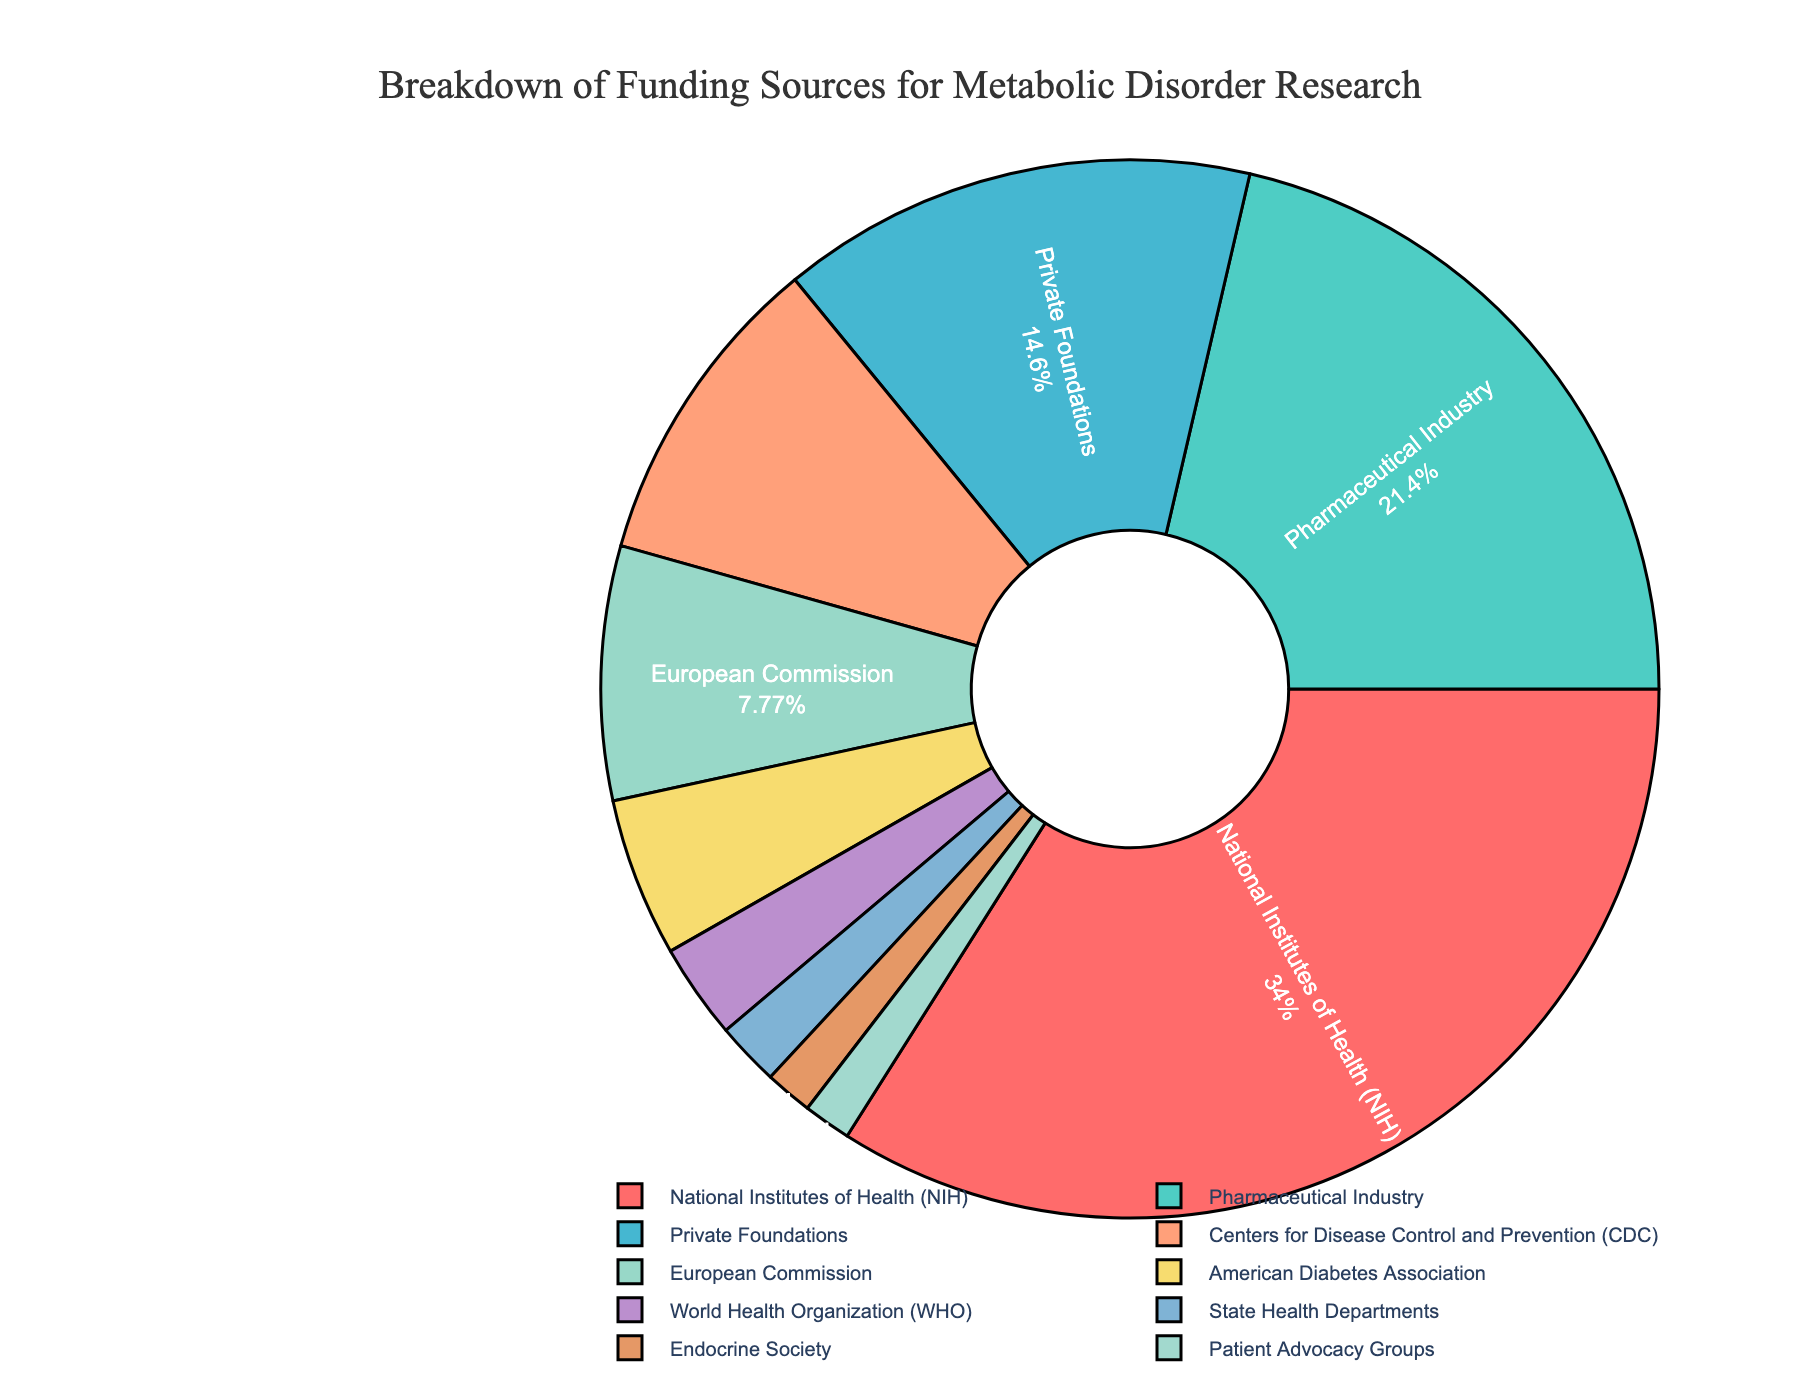Which funding source contributes the largest percentage? The pie chart shows that the National Institutes of Health (NIH) segment is the largest. Therefore, NIH contributes the largest percentage to funding.
Answer: National Institutes of Health (NIH) What is the combined percentage of funding from the CDC and the European Commission? From the pie chart, the CDC contributes 10% and the European Commission contributes 8%. Adding these together, we get 10% + 8% = 18%.
Answer: 18% How much more funding does the National Institutes of Health (NIH) receive compared to the Pharmaceutical Industry? According to the chart, the NIH receives 35% while the Pharmaceutical Industry receives 22%. The difference is 35% - 22% = 13%.
Answer: 13% Which funding sources contribute less than 5% individually? The pie chart shows that the American Diabetes Association, World Health Organization (WHO), State Health Departments, Endocrine Society, and Patient Advocacy Groups each contribute less than 5%.
Answer: American Diabetes Association, World Health Organization (WHO), State Health Departments, Endocrine Society, Patient Advocacy Groups Which color represents the Pharmaceutical Industry's funding? From the pie chart, the Pharmaceutical Industry’s segment is colored in green.
Answer: Green What is the difference in funding percentage between private foundations and the American Diabetes Association? The pie chart indicates that private foundations contribute 15% and the American Diabetes Association contributes 5%. The difference is 15% - 5% = 10%.
Answer: 10% Rank the top three funding sources based on percentage share. The top three funding sources based on the pie chart are 1) National Institutes of Health (NIH) with 35%, 2) Pharmaceutical Industry with 22%, and 3) Private Foundations with 15%.
Answer: National Institutes of Health (NIH), Pharmaceutical Industry, Private Foundations How much more funding, in percentage points, do private foundations receive compared to the European Commission? The pie chart shows private foundations receive 15%, while the European Commission receives 8%, so private foundations receive 15% - 8% = 7% more.
Answer: 7% What is the cumulative percentage of funding from sources contributing less than or equal to 15% individually? From the pie chart: Private Foundations (15%), CDC (10%), European Commission (8%), American Diabetes Association (5%), WHO (3%), State Health Departments (2%), Endocrine Society (1.5%), Patient Advocacy Groups (1.5%). Adding them: 15% + 10% + 8% + 5% + 3% + 2% + 1.5% + 1.5% = 46%.
Answer: 46% How does funding from State Health Departments compare to funding from the Endocrine Society and Patient Advocacy Groups combined? The pie chart shows State Health Departments contribute 2%, while the Endocrine Society and Patient Advocacy Groups each contribute 1.5%. Combined, they contribute 1.5% + 1.5% = 3%. Therefore, State Health Departments contribute less.
Answer: Less 